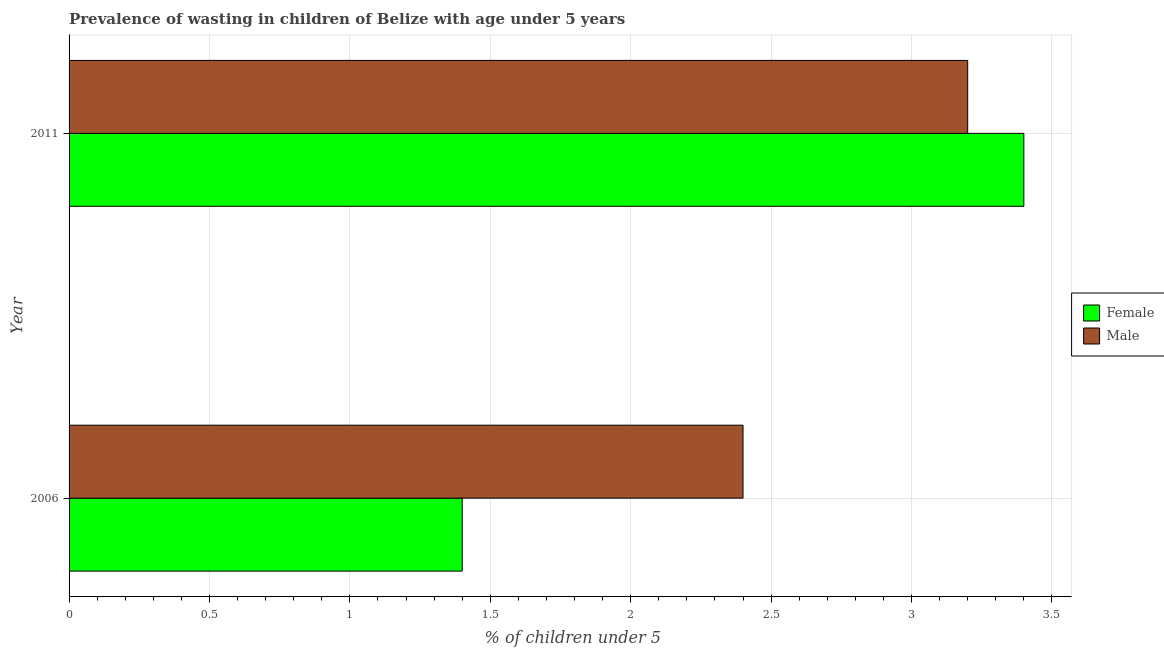How many different coloured bars are there?
Keep it short and to the point. 2. How many groups of bars are there?
Provide a short and direct response. 2. Are the number of bars per tick equal to the number of legend labels?
Your answer should be very brief. Yes. How many bars are there on the 2nd tick from the bottom?
Keep it short and to the point. 2. What is the label of the 2nd group of bars from the top?
Provide a succinct answer. 2006. In how many cases, is the number of bars for a given year not equal to the number of legend labels?
Give a very brief answer. 0. What is the percentage of undernourished female children in 2011?
Offer a terse response. 3.4. Across all years, what is the maximum percentage of undernourished male children?
Your response must be concise. 3.2. Across all years, what is the minimum percentage of undernourished male children?
Provide a short and direct response. 2.4. In which year was the percentage of undernourished male children maximum?
Provide a short and direct response. 2011. In which year was the percentage of undernourished male children minimum?
Ensure brevity in your answer.  2006. What is the total percentage of undernourished male children in the graph?
Your answer should be compact. 5.6. What is the difference between the percentage of undernourished male children in 2006 and that in 2011?
Provide a short and direct response. -0.8. What is the difference between the percentage of undernourished male children in 2006 and the percentage of undernourished female children in 2011?
Keep it short and to the point. -1. What is the average percentage of undernourished female children per year?
Your answer should be compact. 2.4. In how many years, is the percentage of undernourished male children greater than 1.7 %?
Provide a succinct answer. 2. What is the ratio of the percentage of undernourished female children in 2006 to that in 2011?
Keep it short and to the point. 0.41. Is the percentage of undernourished female children in 2006 less than that in 2011?
Your answer should be very brief. Yes. Is the difference between the percentage of undernourished male children in 2006 and 2011 greater than the difference between the percentage of undernourished female children in 2006 and 2011?
Ensure brevity in your answer.  Yes. What does the 1st bar from the bottom in 2011 represents?
Your response must be concise. Female. How many bars are there?
Your response must be concise. 4. How many years are there in the graph?
Ensure brevity in your answer.  2. Does the graph contain any zero values?
Your answer should be compact. No. Where does the legend appear in the graph?
Provide a succinct answer. Center right. How are the legend labels stacked?
Ensure brevity in your answer.  Vertical. What is the title of the graph?
Offer a very short reply. Prevalence of wasting in children of Belize with age under 5 years. What is the label or title of the X-axis?
Ensure brevity in your answer.   % of children under 5. What is the  % of children under 5 in Female in 2006?
Your answer should be compact. 1.4. What is the  % of children under 5 of Male in 2006?
Provide a short and direct response. 2.4. What is the  % of children under 5 in Female in 2011?
Your answer should be compact. 3.4. What is the  % of children under 5 of Male in 2011?
Your answer should be compact. 3.2. Across all years, what is the maximum  % of children under 5 of Female?
Make the answer very short. 3.4. Across all years, what is the maximum  % of children under 5 in Male?
Offer a terse response. 3.2. Across all years, what is the minimum  % of children under 5 of Female?
Offer a very short reply. 1.4. Across all years, what is the minimum  % of children under 5 in Male?
Provide a short and direct response. 2.4. What is the total  % of children under 5 in Male in the graph?
Offer a very short reply. 5.6. What is the difference between the  % of children under 5 in Female in 2006 and that in 2011?
Give a very brief answer. -2. What is the difference between the  % of children under 5 of Male in 2006 and that in 2011?
Give a very brief answer. -0.8. What is the average  % of children under 5 in Male per year?
Your answer should be compact. 2.8. In the year 2011, what is the difference between the  % of children under 5 of Female and  % of children under 5 of Male?
Your answer should be compact. 0.2. What is the ratio of the  % of children under 5 of Female in 2006 to that in 2011?
Offer a terse response. 0.41. What is the ratio of the  % of children under 5 of Male in 2006 to that in 2011?
Make the answer very short. 0.75. What is the difference between the highest and the lowest  % of children under 5 of Female?
Make the answer very short. 2. 